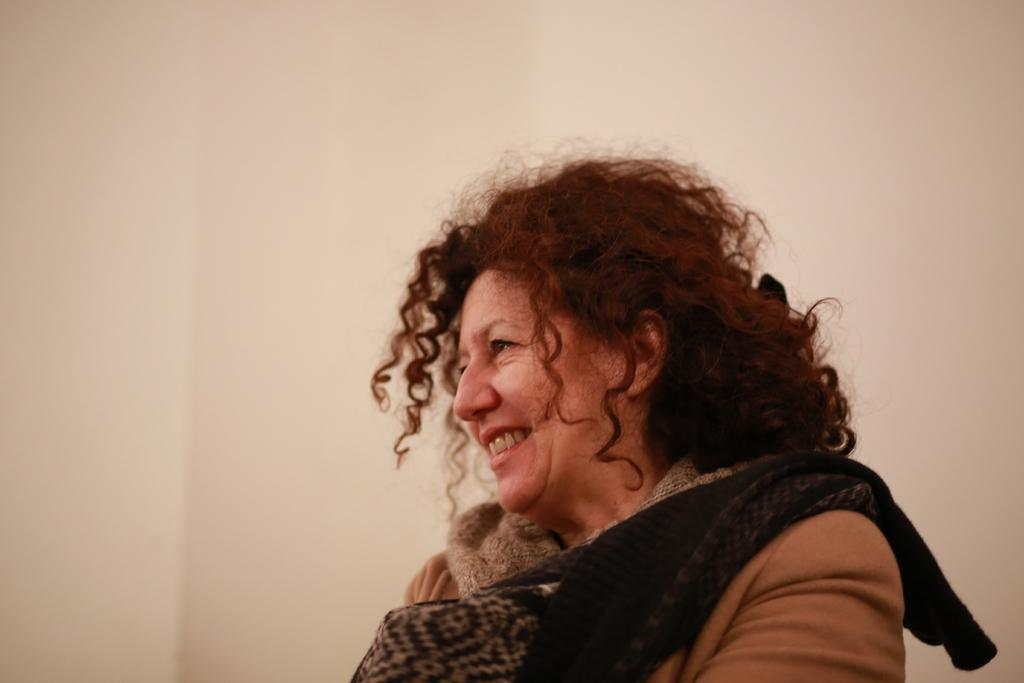Who is the main subject in the image? There is a woman in the image. What is the woman wearing? The woman is wearing a brown colored jacket. Is there any other clothing item visible on the woman? Yes, there is a black colored cloth on the woman. What can be seen in the background of the image? There is a cream colored surface in the background of the image. Can you tell me how many snakes are crawling on the woman in the image? There are no snakes present in the image; the woman is wearing a black colored cloth. What type of coal is visible on the cream colored surface in the image? There is no coal present in the image; the background features a cream colored surface. 